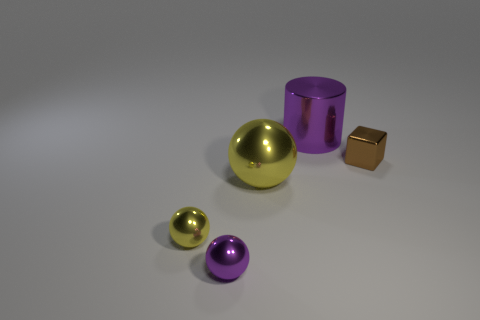What is the ball to the left of the purple metallic thing that is in front of the small cube made of?
Give a very brief answer. Metal. Is the number of purple metallic things behind the large yellow object less than the number of big cylinders in front of the brown block?
Your answer should be very brief. No. How many brown things are tiny objects or large metallic spheres?
Provide a short and direct response. 1. Are there the same number of objects that are behind the small shiny block and tiny metallic balls?
Ensure brevity in your answer.  No. What number of things are either tiny blue metal cylinders or objects that are on the right side of the small yellow object?
Your answer should be very brief. 4. Is the metallic cylinder the same color as the large ball?
Your response must be concise. No. Is there a small cyan ball made of the same material as the small purple sphere?
Ensure brevity in your answer.  No. What color is the large metal thing that is the same shape as the tiny yellow object?
Give a very brief answer. Yellow. Does the purple cylinder have the same material as the sphere that is in front of the small yellow sphere?
Your answer should be very brief. Yes. What shape is the tiny thing that is right of the big object in front of the big metallic cylinder?
Offer a terse response. Cube. 